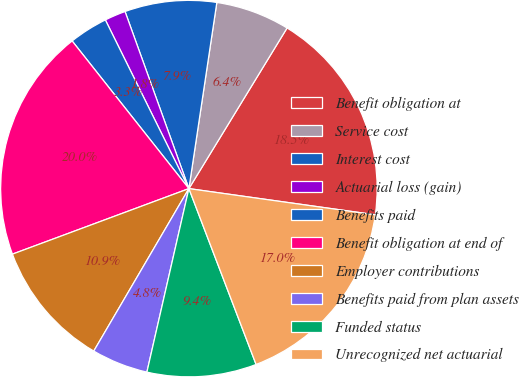Convert chart. <chart><loc_0><loc_0><loc_500><loc_500><pie_chart><fcel>Benefit obligation at<fcel>Service cost<fcel>Interest cost<fcel>Actuarial loss (gain)<fcel>Benefits paid<fcel>Benefit obligation at end of<fcel>Employer contributions<fcel>Benefits paid from plan assets<fcel>Funded status<fcel>Unrecognized net actuarial<nl><fcel>18.49%<fcel>6.36%<fcel>7.88%<fcel>1.81%<fcel>3.33%<fcel>20.01%<fcel>10.91%<fcel>4.85%<fcel>9.39%<fcel>16.97%<nl></chart> 